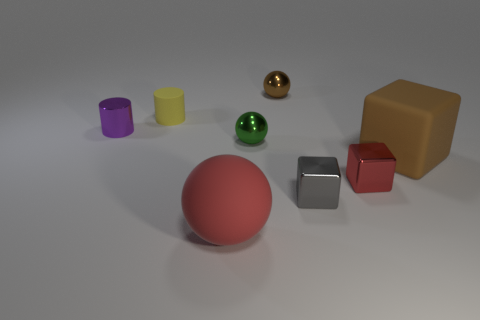There is a red object that is in front of the metal cube that is right of the gray object; what is its size?
Keep it short and to the point. Large. Do the matte cylinder and the large thing right of the tiny green metallic ball have the same color?
Your response must be concise. No. There is a yellow object that is the same size as the red metal block; what is it made of?
Offer a very short reply. Rubber. Are there fewer brown shiny spheres on the right side of the large brown matte thing than small red blocks left of the tiny red cube?
Offer a very short reply. No. The red object that is to the right of the big matte object in front of the brown matte object is what shape?
Keep it short and to the point. Cube. Is there a big matte object?
Offer a very short reply. Yes. The tiny shiny block right of the tiny gray metallic thing is what color?
Keep it short and to the point. Red. There is a object that is the same color as the large rubber cube; what is its material?
Offer a terse response. Metal. Are there any tiny green things to the left of the brown matte block?
Give a very brief answer. Yes. Are there more small brown matte things than tiny purple metal things?
Keep it short and to the point. No. 